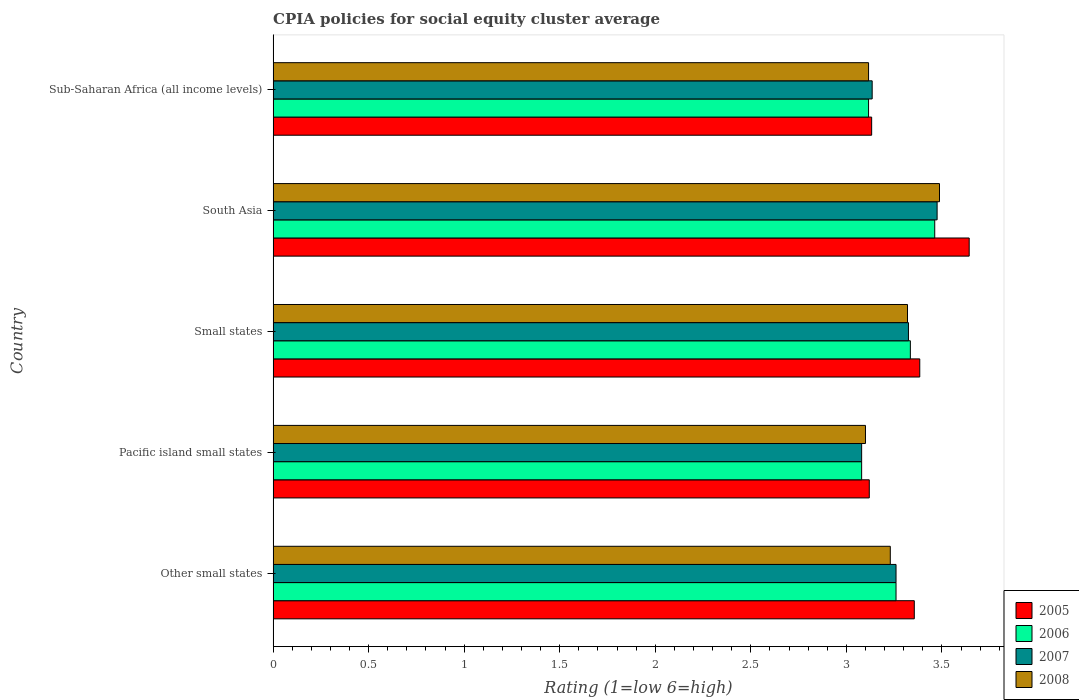How many different coloured bars are there?
Offer a very short reply. 4. Are the number of bars on each tick of the Y-axis equal?
Your response must be concise. Yes. How many bars are there on the 3rd tick from the top?
Provide a succinct answer. 4. How many bars are there on the 5th tick from the bottom?
Offer a terse response. 4. What is the label of the 2nd group of bars from the top?
Make the answer very short. South Asia. In how many cases, is the number of bars for a given country not equal to the number of legend labels?
Give a very brief answer. 0. What is the CPIA rating in 2007 in Other small states?
Give a very brief answer. 3.26. Across all countries, what is the maximum CPIA rating in 2008?
Provide a short and direct response. 3.49. Across all countries, what is the minimum CPIA rating in 2006?
Give a very brief answer. 3.08. In which country was the CPIA rating in 2006 maximum?
Keep it short and to the point. South Asia. In which country was the CPIA rating in 2008 minimum?
Your response must be concise. Pacific island small states. What is the total CPIA rating in 2007 in the graph?
Provide a succinct answer. 16.28. What is the difference between the CPIA rating in 2005 in Small states and that in South Asia?
Provide a short and direct response. -0.26. What is the difference between the CPIA rating in 2007 in Other small states and the CPIA rating in 2006 in Small states?
Offer a terse response. -0.08. What is the average CPIA rating in 2007 per country?
Your response must be concise. 3.26. What is the difference between the CPIA rating in 2005 and CPIA rating in 2007 in Pacific island small states?
Offer a very short reply. 0.04. What is the ratio of the CPIA rating in 2005 in Other small states to that in Small states?
Make the answer very short. 0.99. Is the CPIA rating in 2008 in Pacific island small states less than that in Sub-Saharan Africa (all income levels)?
Your response must be concise. Yes. Is the difference between the CPIA rating in 2005 in Small states and Sub-Saharan Africa (all income levels) greater than the difference between the CPIA rating in 2007 in Small states and Sub-Saharan Africa (all income levels)?
Keep it short and to the point. Yes. What is the difference between the highest and the second highest CPIA rating in 2006?
Ensure brevity in your answer.  0.13. What is the difference between the highest and the lowest CPIA rating in 2005?
Provide a short and direct response. 0.52. In how many countries, is the CPIA rating in 2005 greater than the average CPIA rating in 2005 taken over all countries?
Offer a terse response. 3. Is the sum of the CPIA rating in 2008 in Small states and Sub-Saharan Africa (all income levels) greater than the maximum CPIA rating in 2006 across all countries?
Your response must be concise. Yes. Is it the case that in every country, the sum of the CPIA rating in 2005 and CPIA rating in 2006 is greater than the CPIA rating in 2008?
Your response must be concise. Yes. Are the values on the major ticks of X-axis written in scientific E-notation?
Provide a short and direct response. No. Does the graph contain grids?
Your answer should be very brief. No. Where does the legend appear in the graph?
Offer a very short reply. Bottom right. How many legend labels are there?
Make the answer very short. 4. How are the legend labels stacked?
Give a very brief answer. Vertical. What is the title of the graph?
Provide a succinct answer. CPIA policies for social equity cluster average. What is the label or title of the X-axis?
Your answer should be compact. Rating (1=low 6=high). What is the Rating (1=low 6=high) in 2005 in Other small states?
Give a very brief answer. 3.36. What is the Rating (1=low 6=high) in 2006 in Other small states?
Provide a short and direct response. 3.26. What is the Rating (1=low 6=high) of 2007 in Other small states?
Make the answer very short. 3.26. What is the Rating (1=low 6=high) of 2008 in Other small states?
Provide a short and direct response. 3.23. What is the Rating (1=low 6=high) of 2005 in Pacific island small states?
Keep it short and to the point. 3.12. What is the Rating (1=low 6=high) of 2006 in Pacific island small states?
Offer a very short reply. 3.08. What is the Rating (1=low 6=high) in 2007 in Pacific island small states?
Offer a very short reply. 3.08. What is the Rating (1=low 6=high) in 2005 in Small states?
Provide a short and direct response. 3.38. What is the Rating (1=low 6=high) of 2006 in Small states?
Your answer should be very brief. 3.33. What is the Rating (1=low 6=high) of 2007 in Small states?
Your answer should be compact. 3.33. What is the Rating (1=low 6=high) of 2008 in Small states?
Your answer should be very brief. 3.32. What is the Rating (1=low 6=high) of 2005 in South Asia?
Ensure brevity in your answer.  3.64. What is the Rating (1=low 6=high) of 2006 in South Asia?
Make the answer very short. 3.46. What is the Rating (1=low 6=high) of 2007 in South Asia?
Your answer should be very brief. 3.48. What is the Rating (1=low 6=high) of 2008 in South Asia?
Offer a terse response. 3.49. What is the Rating (1=low 6=high) in 2005 in Sub-Saharan Africa (all income levels)?
Keep it short and to the point. 3.13. What is the Rating (1=low 6=high) in 2006 in Sub-Saharan Africa (all income levels)?
Keep it short and to the point. 3.12. What is the Rating (1=low 6=high) of 2007 in Sub-Saharan Africa (all income levels)?
Make the answer very short. 3.14. What is the Rating (1=low 6=high) of 2008 in Sub-Saharan Africa (all income levels)?
Give a very brief answer. 3.12. Across all countries, what is the maximum Rating (1=low 6=high) in 2005?
Offer a terse response. 3.64. Across all countries, what is the maximum Rating (1=low 6=high) of 2006?
Provide a succinct answer. 3.46. Across all countries, what is the maximum Rating (1=low 6=high) of 2007?
Provide a succinct answer. 3.48. Across all countries, what is the maximum Rating (1=low 6=high) of 2008?
Make the answer very short. 3.49. Across all countries, what is the minimum Rating (1=low 6=high) of 2005?
Provide a short and direct response. 3.12. Across all countries, what is the minimum Rating (1=low 6=high) of 2006?
Keep it short and to the point. 3.08. Across all countries, what is the minimum Rating (1=low 6=high) in 2007?
Your answer should be very brief. 3.08. Across all countries, what is the minimum Rating (1=low 6=high) of 2008?
Make the answer very short. 3.1. What is the total Rating (1=low 6=high) in 2005 in the graph?
Provide a succinct answer. 16.64. What is the total Rating (1=low 6=high) in 2006 in the graph?
Your response must be concise. 16.25. What is the total Rating (1=low 6=high) of 2007 in the graph?
Your answer should be compact. 16.28. What is the total Rating (1=low 6=high) in 2008 in the graph?
Ensure brevity in your answer.  16.25. What is the difference between the Rating (1=low 6=high) of 2005 in Other small states and that in Pacific island small states?
Keep it short and to the point. 0.24. What is the difference between the Rating (1=low 6=high) in 2006 in Other small states and that in Pacific island small states?
Your answer should be compact. 0.18. What is the difference between the Rating (1=low 6=high) of 2007 in Other small states and that in Pacific island small states?
Ensure brevity in your answer.  0.18. What is the difference between the Rating (1=low 6=high) of 2008 in Other small states and that in Pacific island small states?
Your answer should be very brief. 0.13. What is the difference between the Rating (1=low 6=high) of 2005 in Other small states and that in Small states?
Your response must be concise. -0.03. What is the difference between the Rating (1=low 6=high) of 2006 in Other small states and that in Small states?
Give a very brief answer. -0.07. What is the difference between the Rating (1=low 6=high) in 2007 in Other small states and that in Small states?
Give a very brief answer. -0.07. What is the difference between the Rating (1=low 6=high) in 2008 in Other small states and that in Small states?
Give a very brief answer. -0.09. What is the difference between the Rating (1=low 6=high) in 2005 in Other small states and that in South Asia?
Your answer should be very brief. -0.29. What is the difference between the Rating (1=low 6=high) in 2006 in Other small states and that in South Asia?
Offer a very short reply. -0.2. What is the difference between the Rating (1=low 6=high) of 2007 in Other small states and that in South Asia?
Offer a terse response. -0.21. What is the difference between the Rating (1=low 6=high) in 2008 in Other small states and that in South Asia?
Provide a succinct answer. -0.26. What is the difference between the Rating (1=low 6=high) of 2005 in Other small states and that in Sub-Saharan Africa (all income levels)?
Provide a short and direct response. 0.22. What is the difference between the Rating (1=low 6=high) in 2006 in Other small states and that in Sub-Saharan Africa (all income levels)?
Provide a short and direct response. 0.14. What is the difference between the Rating (1=low 6=high) in 2007 in Other small states and that in Sub-Saharan Africa (all income levels)?
Your answer should be very brief. 0.12. What is the difference between the Rating (1=low 6=high) in 2008 in Other small states and that in Sub-Saharan Africa (all income levels)?
Your answer should be compact. 0.11. What is the difference between the Rating (1=low 6=high) in 2005 in Pacific island small states and that in Small states?
Your answer should be compact. -0.26. What is the difference between the Rating (1=low 6=high) of 2006 in Pacific island small states and that in Small states?
Your response must be concise. -0.26. What is the difference between the Rating (1=low 6=high) in 2007 in Pacific island small states and that in Small states?
Offer a terse response. -0.24. What is the difference between the Rating (1=low 6=high) of 2008 in Pacific island small states and that in Small states?
Your answer should be compact. -0.22. What is the difference between the Rating (1=low 6=high) of 2005 in Pacific island small states and that in South Asia?
Offer a very short reply. -0.52. What is the difference between the Rating (1=low 6=high) of 2006 in Pacific island small states and that in South Asia?
Your response must be concise. -0.38. What is the difference between the Rating (1=low 6=high) of 2007 in Pacific island small states and that in South Asia?
Your response must be concise. -0.4. What is the difference between the Rating (1=low 6=high) of 2008 in Pacific island small states and that in South Asia?
Ensure brevity in your answer.  -0.39. What is the difference between the Rating (1=low 6=high) of 2005 in Pacific island small states and that in Sub-Saharan Africa (all income levels)?
Keep it short and to the point. -0.01. What is the difference between the Rating (1=low 6=high) of 2006 in Pacific island small states and that in Sub-Saharan Africa (all income levels)?
Offer a very short reply. -0.04. What is the difference between the Rating (1=low 6=high) in 2007 in Pacific island small states and that in Sub-Saharan Africa (all income levels)?
Your response must be concise. -0.06. What is the difference between the Rating (1=low 6=high) of 2008 in Pacific island small states and that in Sub-Saharan Africa (all income levels)?
Give a very brief answer. -0.02. What is the difference between the Rating (1=low 6=high) in 2005 in Small states and that in South Asia?
Keep it short and to the point. -0.26. What is the difference between the Rating (1=low 6=high) in 2006 in Small states and that in South Asia?
Keep it short and to the point. -0.13. What is the difference between the Rating (1=low 6=high) in 2007 in Small states and that in South Asia?
Your answer should be very brief. -0.15. What is the difference between the Rating (1=low 6=high) in 2008 in Small states and that in South Asia?
Provide a succinct answer. -0.17. What is the difference between the Rating (1=low 6=high) of 2005 in Small states and that in Sub-Saharan Africa (all income levels)?
Give a very brief answer. 0.25. What is the difference between the Rating (1=low 6=high) of 2006 in Small states and that in Sub-Saharan Africa (all income levels)?
Provide a short and direct response. 0.22. What is the difference between the Rating (1=low 6=high) in 2007 in Small states and that in Sub-Saharan Africa (all income levels)?
Keep it short and to the point. 0.19. What is the difference between the Rating (1=low 6=high) in 2008 in Small states and that in Sub-Saharan Africa (all income levels)?
Provide a short and direct response. 0.2. What is the difference between the Rating (1=low 6=high) in 2005 in South Asia and that in Sub-Saharan Africa (all income levels)?
Keep it short and to the point. 0.51. What is the difference between the Rating (1=low 6=high) of 2006 in South Asia and that in Sub-Saharan Africa (all income levels)?
Your answer should be very brief. 0.35. What is the difference between the Rating (1=low 6=high) in 2007 in South Asia and that in Sub-Saharan Africa (all income levels)?
Provide a short and direct response. 0.34. What is the difference between the Rating (1=low 6=high) of 2008 in South Asia and that in Sub-Saharan Africa (all income levels)?
Your response must be concise. 0.37. What is the difference between the Rating (1=low 6=high) of 2005 in Other small states and the Rating (1=low 6=high) of 2006 in Pacific island small states?
Give a very brief answer. 0.28. What is the difference between the Rating (1=low 6=high) of 2005 in Other small states and the Rating (1=low 6=high) of 2007 in Pacific island small states?
Give a very brief answer. 0.28. What is the difference between the Rating (1=low 6=high) of 2005 in Other small states and the Rating (1=low 6=high) of 2008 in Pacific island small states?
Provide a succinct answer. 0.26. What is the difference between the Rating (1=low 6=high) of 2006 in Other small states and the Rating (1=low 6=high) of 2007 in Pacific island small states?
Provide a succinct answer. 0.18. What is the difference between the Rating (1=low 6=high) in 2006 in Other small states and the Rating (1=low 6=high) in 2008 in Pacific island small states?
Give a very brief answer. 0.16. What is the difference between the Rating (1=low 6=high) of 2007 in Other small states and the Rating (1=low 6=high) of 2008 in Pacific island small states?
Offer a terse response. 0.16. What is the difference between the Rating (1=low 6=high) in 2005 in Other small states and the Rating (1=low 6=high) in 2006 in Small states?
Provide a short and direct response. 0.02. What is the difference between the Rating (1=low 6=high) in 2005 in Other small states and the Rating (1=low 6=high) in 2007 in Small states?
Your response must be concise. 0.03. What is the difference between the Rating (1=low 6=high) of 2005 in Other small states and the Rating (1=low 6=high) of 2008 in Small states?
Your answer should be compact. 0.04. What is the difference between the Rating (1=low 6=high) of 2006 in Other small states and the Rating (1=low 6=high) of 2007 in Small states?
Provide a short and direct response. -0.07. What is the difference between the Rating (1=low 6=high) of 2006 in Other small states and the Rating (1=low 6=high) of 2008 in Small states?
Offer a terse response. -0.06. What is the difference between the Rating (1=low 6=high) in 2007 in Other small states and the Rating (1=low 6=high) in 2008 in Small states?
Make the answer very short. -0.06. What is the difference between the Rating (1=low 6=high) of 2005 in Other small states and the Rating (1=low 6=high) of 2006 in South Asia?
Keep it short and to the point. -0.11. What is the difference between the Rating (1=low 6=high) of 2005 in Other small states and the Rating (1=low 6=high) of 2007 in South Asia?
Provide a succinct answer. -0.12. What is the difference between the Rating (1=low 6=high) of 2005 in Other small states and the Rating (1=low 6=high) of 2008 in South Asia?
Give a very brief answer. -0.13. What is the difference between the Rating (1=low 6=high) of 2006 in Other small states and the Rating (1=low 6=high) of 2007 in South Asia?
Your answer should be very brief. -0.21. What is the difference between the Rating (1=low 6=high) of 2006 in Other small states and the Rating (1=low 6=high) of 2008 in South Asia?
Offer a very short reply. -0.23. What is the difference between the Rating (1=low 6=high) of 2007 in Other small states and the Rating (1=low 6=high) of 2008 in South Asia?
Provide a short and direct response. -0.23. What is the difference between the Rating (1=low 6=high) in 2005 in Other small states and the Rating (1=low 6=high) in 2006 in Sub-Saharan Africa (all income levels)?
Your answer should be very brief. 0.24. What is the difference between the Rating (1=low 6=high) in 2005 in Other small states and the Rating (1=low 6=high) in 2007 in Sub-Saharan Africa (all income levels)?
Your answer should be compact. 0.22. What is the difference between the Rating (1=low 6=high) in 2005 in Other small states and the Rating (1=low 6=high) in 2008 in Sub-Saharan Africa (all income levels)?
Provide a succinct answer. 0.24. What is the difference between the Rating (1=low 6=high) of 2006 in Other small states and the Rating (1=low 6=high) of 2007 in Sub-Saharan Africa (all income levels)?
Give a very brief answer. 0.12. What is the difference between the Rating (1=low 6=high) of 2006 in Other small states and the Rating (1=low 6=high) of 2008 in Sub-Saharan Africa (all income levels)?
Provide a succinct answer. 0.14. What is the difference between the Rating (1=low 6=high) in 2007 in Other small states and the Rating (1=low 6=high) in 2008 in Sub-Saharan Africa (all income levels)?
Give a very brief answer. 0.14. What is the difference between the Rating (1=low 6=high) in 2005 in Pacific island small states and the Rating (1=low 6=high) in 2006 in Small states?
Your response must be concise. -0.21. What is the difference between the Rating (1=low 6=high) in 2005 in Pacific island small states and the Rating (1=low 6=high) in 2007 in Small states?
Your answer should be very brief. -0.2. What is the difference between the Rating (1=low 6=high) of 2006 in Pacific island small states and the Rating (1=low 6=high) of 2007 in Small states?
Keep it short and to the point. -0.24. What is the difference between the Rating (1=low 6=high) in 2006 in Pacific island small states and the Rating (1=low 6=high) in 2008 in Small states?
Your response must be concise. -0.24. What is the difference between the Rating (1=low 6=high) of 2007 in Pacific island small states and the Rating (1=low 6=high) of 2008 in Small states?
Provide a succinct answer. -0.24. What is the difference between the Rating (1=low 6=high) of 2005 in Pacific island small states and the Rating (1=low 6=high) of 2006 in South Asia?
Your answer should be very brief. -0.34. What is the difference between the Rating (1=low 6=high) of 2005 in Pacific island small states and the Rating (1=low 6=high) of 2007 in South Asia?
Make the answer very short. -0.35. What is the difference between the Rating (1=low 6=high) in 2005 in Pacific island small states and the Rating (1=low 6=high) in 2008 in South Asia?
Offer a terse response. -0.37. What is the difference between the Rating (1=low 6=high) of 2006 in Pacific island small states and the Rating (1=low 6=high) of 2007 in South Asia?
Give a very brief answer. -0.4. What is the difference between the Rating (1=low 6=high) of 2006 in Pacific island small states and the Rating (1=low 6=high) of 2008 in South Asia?
Offer a very short reply. -0.41. What is the difference between the Rating (1=low 6=high) in 2007 in Pacific island small states and the Rating (1=low 6=high) in 2008 in South Asia?
Your answer should be compact. -0.41. What is the difference between the Rating (1=low 6=high) of 2005 in Pacific island small states and the Rating (1=low 6=high) of 2006 in Sub-Saharan Africa (all income levels)?
Provide a succinct answer. 0. What is the difference between the Rating (1=low 6=high) of 2005 in Pacific island small states and the Rating (1=low 6=high) of 2007 in Sub-Saharan Africa (all income levels)?
Offer a terse response. -0.02. What is the difference between the Rating (1=low 6=high) of 2005 in Pacific island small states and the Rating (1=low 6=high) of 2008 in Sub-Saharan Africa (all income levels)?
Your answer should be very brief. 0. What is the difference between the Rating (1=low 6=high) in 2006 in Pacific island small states and the Rating (1=low 6=high) in 2007 in Sub-Saharan Africa (all income levels)?
Your response must be concise. -0.06. What is the difference between the Rating (1=low 6=high) of 2006 in Pacific island small states and the Rating (1=low 6=high) of 2008 in Sub-Saharan Africa (all income levels)?
Keep it short and to the point. -0.04. What is the difference between the Rating (1=low 6=high) of 2007 in Pacific island small states and the Rating (1=low 6=high) of 2008 in Sub-Saharan Africa (all income levels)?
Give a very brief answer. -0.04. What is the difference between the Rating (1=low 6=high) in 2005 in Small states and the Rating (1=low 6=high) in 2006 in South Asia?
Offer a terse response. -0.08. What is the difference between the Rating (1=low 6=high) in 2005 in Small states and the Rating (1=low 6=high) in 2007 in South Asia?
Provide a succinct answer. -0.09. What is the difference between the Rating (1=low 6=high) in 2005 in Small states and the Rating (1=low 6=high) in 2008 in South Asia?
Offer a terse response. -0.1. What is the difference between the Rating (1=low 6=high) of 2006 in Small states and the Rating (1=low 6=high) of 2007 in South Asia?
Your answer should be compact. -0.14. What is the difference between the Rating (1=low 6=high) of 2006 in Small states and the Rating (1=low 6=high) of 2008 in South Asia?
Your response must be concise. -0.15. What is the difference between the Rating (1=low 6=high) in 2007 in Small states and the Rating (1=low 6=high) in 2008 in South Asia?
Your answer should be very brief. -0.16. What is the difference between the Rating (1=low 6=high) of 2005 in Small states and the Rating (1=low 6=high) of 2006 in Sub-Saharan Africa (all income levels)?
Keep it short and to the point. 0.27. What is the difference between the Rating (1=low 6=high) of 2005 in Small states and the Rating (1=low 6=high) of 2007 in Sub-Saharan Africa (all income levels)?
Your response must be concise. 0.25. What is the difference between the Rating (1=low 6=high) in 2005 in Small states and the Rating (1=low 6=high) in 2008 in Sub-Saharan Africa (all income levels)?
Ensure brevity in your answer.  0.27. What is the difference between the Rating (1=low 6=high) in 2006 in Small states and the Rating (1=low 6=high) in 2007 in Sub-Saharan Africa (all income levels)?
Make the answer very short. 0.2. What is the difference between the Rating (1=low 6=high) of 2006 in Small states and the Rating (1=low 6=high) of 2008 in Sub-Saharan Africa (all income levels)?
Your answer should be very brief. 0.22. What is the difference between the Rating (1=low 6=high) in 2007 in Small states and the Rating (1=low 6=high) in 2008 in Sub-Saharan Africa (all income levels)?
Ensure brevity in your answer.  0.21. What is the difference between the Rating (1=low 6=high) of 2005 in South Asia and the Rating (1=low 6=high) of 2006 in Sub-Saharan Africa (all income levels)?
Your answer should be compact. 0.53. What is the difference between the Rating (1=low 6=high) of 2005 in South Asia and the Rating (1=low 6=high) of 2007 in Sub-Saharan Africa (all income levels)?
Make the answer very short. 0.51. What is the difference between the Rating (1=low 6=high) of 2005 in South Asia and the Rating (1=low 6=high) of 2008 in Sub-Saharan Africa (all income levels)?
Your response must be concise. 0.53. What is the difference between the Rating (1=low 6=high) in 2006 in South Asia and the Rating (1=low 6=high) in 2007 in Sub-Saharan Africa (all income levels)?
Ensure brevity in your answer.  0.33. What is the difference between the Rating (1=low 6=high) in 2006 in South Asia and the Rating (1=low 6=high) in 2008 in Sub-Saharan Africa (all income levels)?
Your answer should be very brief. 0.35. What is the difference between the Rating (1=low 6=high) of 2007 in South Asia and the Rating (1=low 6=high) of 2008 in Sub-Saharan Africa (all income levels)?
Your answer should be very brief. 0.36. What is the average Rating (1=low 6=high) of 2005 per country?
Your answer should be compact. 3.33. What is the average Rating (1=low 6=high) in 2006 per country?
Your response must be concise. 3.25. What is the average Rating (1=low 6=high) of 2007 per country?
Provide a succinct answer. 3.25. What is the average Rating (1=low 6=high) in 2008 per country?
Give a very brief answer. 3.25. What is the difference between the Rating (1=low 6=high) of 2005 and Rating (1=low 6=high) of 2006 in Other small states?
Keep it short and to the point. 0.1. What is the difference between the Rating (1=low 6=high) of 2005 and Rating (1=low 6=high) of 2007 in Other small states?
Keep it short and to the point. 0.1. What is the difference between the Rating (1=low 6=high) of 2005 and Rating (1=low 6=high) of 2008 in Other small states?
Ensure brevity in your answer.  0.13. What is the difference between the Rating (1=low 6=high) in 2006 and Rating (1=low 6=high) in 2007 in Other small states?
Your response must be concise. 0. What is the difference between the Rating (1=low 6=high) of 2006 and Rating (1=low 6=high) of 2007 in Pacific island small states?
Give a very brief answer. 0. What is the difference between the Rating (1=low 6=high) of 2006 and Rating (1=low 6=high) of 2008 in Pacific island small states?
Your answer should be very brief. -0.02. What is the difference between the Rating (1=low 6=high) of 2007 and Rating (1=low 6=high) of 2008 in Pacific island small states?
Provide a short and direct response. -0.02. What is the difference between the Rating (1=low 6=high) of 2005 and Rating (1=low 6=high) of 2006 in Small states?
Your answer should be very brief. 0.05. What is the difference between the Rating (1=low 6=high) of 2005 and Rating (1=low 6=high) of 2007 in Small states?
Give a very brief answer. 0.06. What is the difference between the Rating (1=low 6=high) of 2005 and Rating (1=low 6=high) of 2008 in Small states?
Ensure brevity in your answer.  0.06. What is the difference between the Rating (1=low 6=high) in 2006 and Rating (1=low 6=high) in 2008 in Small states?
Give a very brief answer. 0.01. What is the difference between the Rating (1=low 6=high) of 2007 and Rating (1=low 6=high) of 2008 in Small states?
Provide a succinct answer. 0.01. What is the difference between the Rating (1=low 6=high) of 2005 and Rating (1=low 6=high) of 2006 in South Asia?
Make the answer very short. 0.18. What is the difference between the Rating (1=low 6=high) in 2005 and Rating (1=low 6=high) in 2007 in South Asia?
Offer a terse response. 0.17. What is the difference between the Rating (1=low 6=high) of 2005 and Rating (1=low 6=high) of 2008 in South Asia?
Your response must be concise. 0.16. What is the difference between the Rating (1=low 6=high) in 2006 and Rating (1=low 6=high) in 2007 in South Asia?
Your response must be concise. -0.01. What is the difference between the Rating (1=low 6=high) of 2006 and Rating (1=low 6=high) of 2008 in South Asia?
Keep it short and to the point. -0.03. What is the difference between the Rating (1=low 6=high) of 2007 and Rating (1=low 6=high) of 2008 in South Asia?
Keep it short and to the point. -0.01. What is the difference between the Rating (1=low 6=high) of 2005 and Rating (1=low 6=high) of 2006 in Sub-Saharan Africa (all income levels)?
Make the answer very short. 0.02. What is the difference between the Rating (1=low 6=high) of 2005 and Rating (1=low 6=high) of 2007 in Sub-Saharan Africa (all income levels)?
Keep it short and to the point. -0. What is the difference between the Rating (1=low 6=high) of 2005 and Rating (1=low 6=high) of 2008 in Sub-Saharan Africa (all income levels)?
Your answer should be compact. 0.02. What is the difference between the Rating (1=low 6=high) of 2006 and Rating (1=low 6=high) of 2007 in Sub-Saharan Africa (all income levels)?
Your answer should be compact. -0.02. What is the difference between the Rating (1=low 6=high) in 2006 and Rating (1=low 6=high) in 2008 in Sub-Saharan Africa (all income levels)?
Your answer should be very brief. 0. What is the difference between the Rating (1=low 6=high) in 2007 and Rating (1=low 6=high) in 2008 in Sub-Saharan Africa (all income levels)?
Ensure brevity in your answer.  0.02. What is the ratio of the Rating (1=low 6=high) in 2005 in Other small states to that in Pacific island small states?
Offer a terse response. 1.08. What is the ratio of the Rating (1=low 6=high) in 2006 in Other small states to that in Pacific island small states?
Ensure brevity in your answer.  1.06. What is the ratio of the Rating (1=low 6=high) of 2007 in Other small states to that in Pacific island small states?
Give a very brief answer. 1.06. What is the ratio of the Rating (1=low 6=high) in 2008 in Other small states to that in Pacific island small states?
Make the answer very short. 1.04. What is the ratio of the Rating (1=low 6=high) of 2006 in Other small states to that in Small states?
Ensure brevity in your answer.  0.98. What is the ratio of the Rating (1=low 6=high) of 2007 in Other small states to that in Small states?
Provide a succinct answer. 0.98. What is the ratio of the Rating (1=low 6=high) in 2008 in Other small states to that in Small states?
Keep it short and to the point. 0.97. What is the ratio of the Rating (1=low 6=high) in 2005 in Other small states to that in South Asia?
Provide a short and direct response. 0.92. What is the ratio of the Rating (1=low 6=high) in 2006 in Other small states to that in South Asia?
Provide a short and direct response. 0.94. What is the ratio of the Rating (1=low 6=high) in 2007 in Other small states to that in South Asia?
Provide a succinct answer. 0.94. What is the ratio of the Rating (1=low 6=high) of 2008 in Other small states to that in South Asia?
Offer a very short reply. 0.93. What is the ratio of the Rating (1=low 6=high) in 2005 in Other small states to that in Sub-Saharan Africa (all income levels)?
Your response must be concise. 1.07. What is the ratio of the Rating (1=low 6=high) of 2006 in Other small states to that in Sub-Saharan Africa (all income levels)?
Ensure brevity in your answer.  1.05. What is the ratio of the Rating (1=low 6=high) of 2007 in Other small states to that in Sub-Saharan Africa (all income levels)?
Provide a short and direct response. 1.04. What is the ratio of the Rating (1=low 6=high) in 2008 in Other small states to that in Sub-Saharan Africa (all income levels)?
Provide a short and direct response. 1.04. What is the ratio of the Rating (1=low 6=high) of 2005 in Pacific island small states to that in Small states?
Ensure brevity in your answer.  0.92. What is the ratio of the Rating (1=low 6=high) in 2006 in Pacific island small states to that in Small states?
Ensure brevity in your answer.  0.92. What is the ratio of the Rating (1=low 6=high) in 2007 in Pacific island small states to that in Small states?
Offer a very short reply. 0.93. What is the ratio of the Rating (1=low 6=high) of 2008 in Pacific island small states to that in Small states?
Keep it short and to the point. 0.93. What is the ratio of the Rating (1=low 6=high) of 2005 in Pacific island small states to that in South Asia?
Offer a very short reply. 0.86. What is the ratio of the Rating (1=low 6=high) of 2006 in Pacific island small states to that in South Asia?
Provide a succinct answer. 0.89. What is the ratio of the Rating (1=low 6=high) of 2007 in Pacific island small states to that in South Asia?
Ensure brevity in your answer.  0.89. What is the ratio of the Rating (1=low 6=high) of 2005 in Pacific island small states to that in Sub-Saharan Africa (all income levels)?
Your answer should be very brief. 1. What is the ratio of the Rating (1=low 6=high) in 2006 in Pacific island small states to that in Sub-Saharan Africa (all income levels)?
Keep it short and to the point. 0.99. What is the ratio of the Rating (1=low 6=high) in 2007 in Pacific island small states to that in Sub-Saharan Africa (all income levels)?
Give a very brief answer. 0.98. What is the ratio of the Rating (1=low 6=high) in 2005 in Small states to that in South Asia?
Offer a very short reply. 0.93. What is the ratio of the Rating (1=low 6=high) in 2006 in Small states to that in South Asia?
Your answer should be very brief. 0.96. What is the ratio of the Rating (1=low 6=high) of 2007 in Small states to that in South Asia?
Give a very brief answer. 0.96. What is the ratio of the Rating (1=low 6=high) of 2005 in Small states to that in Sub-Saharan Africa (all income levels)?
Provide a short and direct response. 1.08. What is the ratio of the Rating (1=low 6=high) of 2006 in Small states to that in Sub-Saharan Africa (all income levels)?
Your answer should be very brief. 1.07. What is the ratio of the Rating (1=low 6=high) of 2007 in Small states to that in Sub-Saharan Africa (all income levels)?
Provide a short and direct response. 1.06. What is the ratio of the Rating (1=low 6=high) in 2008 in Small states to that in Sub-Saharan Africa (all income levels)?
Your answer should be very brief. 1.07. What is the ratio of the Rating (1=low 6=high) of 2005 in South Asia to that in Sub-Saharan Africa (all income levels)?
Offer a very short reply. 1.16. What is the ratio of the Rating (1=low 6=high) of 2007 in South Asia to that in Sub-Saharan Africa (all income levels)?
Give a very brief answer. 1.11. What is the ratio of the Rating (1=low 6=high) in 2008 in South Asia to that in Sub-Saharan Africa (all income levels)?
Offer a terse response. 1.12. What is the difference between the highest and the second highest Rating (1=low 6=high) of 2005?
Ensure brevity in your answer.  0.26. What is the difference between the highest and the second highest Rating (1=low 6=high) in 2006?
Your answer should be compact. 0.13. What is the difference between the highest and the second highest Rating (1=low 6=high) of 2007?
Provide a short and direct response. 0.15. What is the difference between the highest and the second highest Rating (1=low 6=high) of 2008?
Provide a succinct answer. 0.17. What is the difference between the highest and the lowest Rating (1=low 6=high) of 2005?
Give a very brief answer. 0.52. What is the difference between the highest and the lowest Rating (1=low 6=high) of 2006?
Give a very brief answer. 0.38. What is the difference between the highest and the lowest Rating (1=low 6=high) of 2007?
Offer a terse response. 0.4. What is the difference between the highest and the lowest Rating (1=low 6=high) of 2008?
Keep it short and to the point. 0.39. 